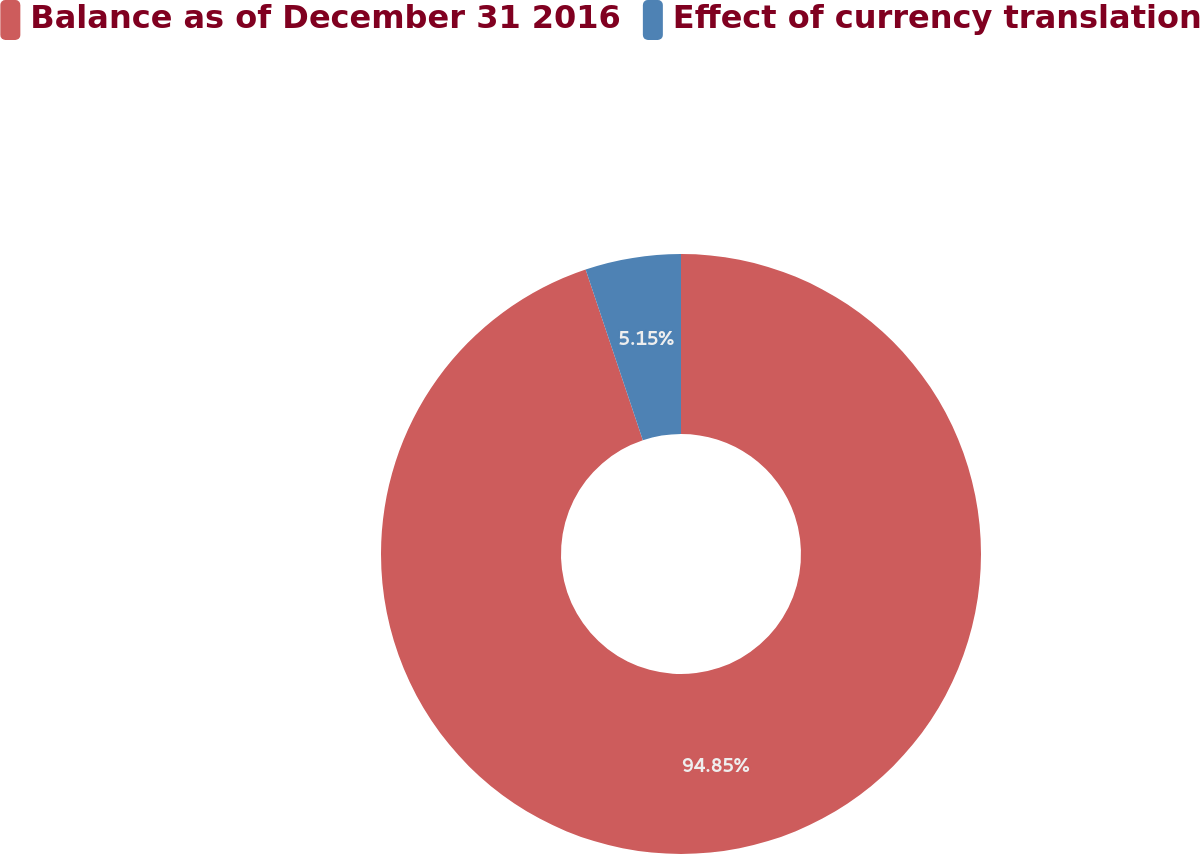<chart> <loc_0><loc_0><loc_500><loc_500><pie_chart><fcel>Balance as of December 31 2016<fcel>Effect of currency translation<nl><fcel>94.85%<fcel>5.15%<nl></chart> 